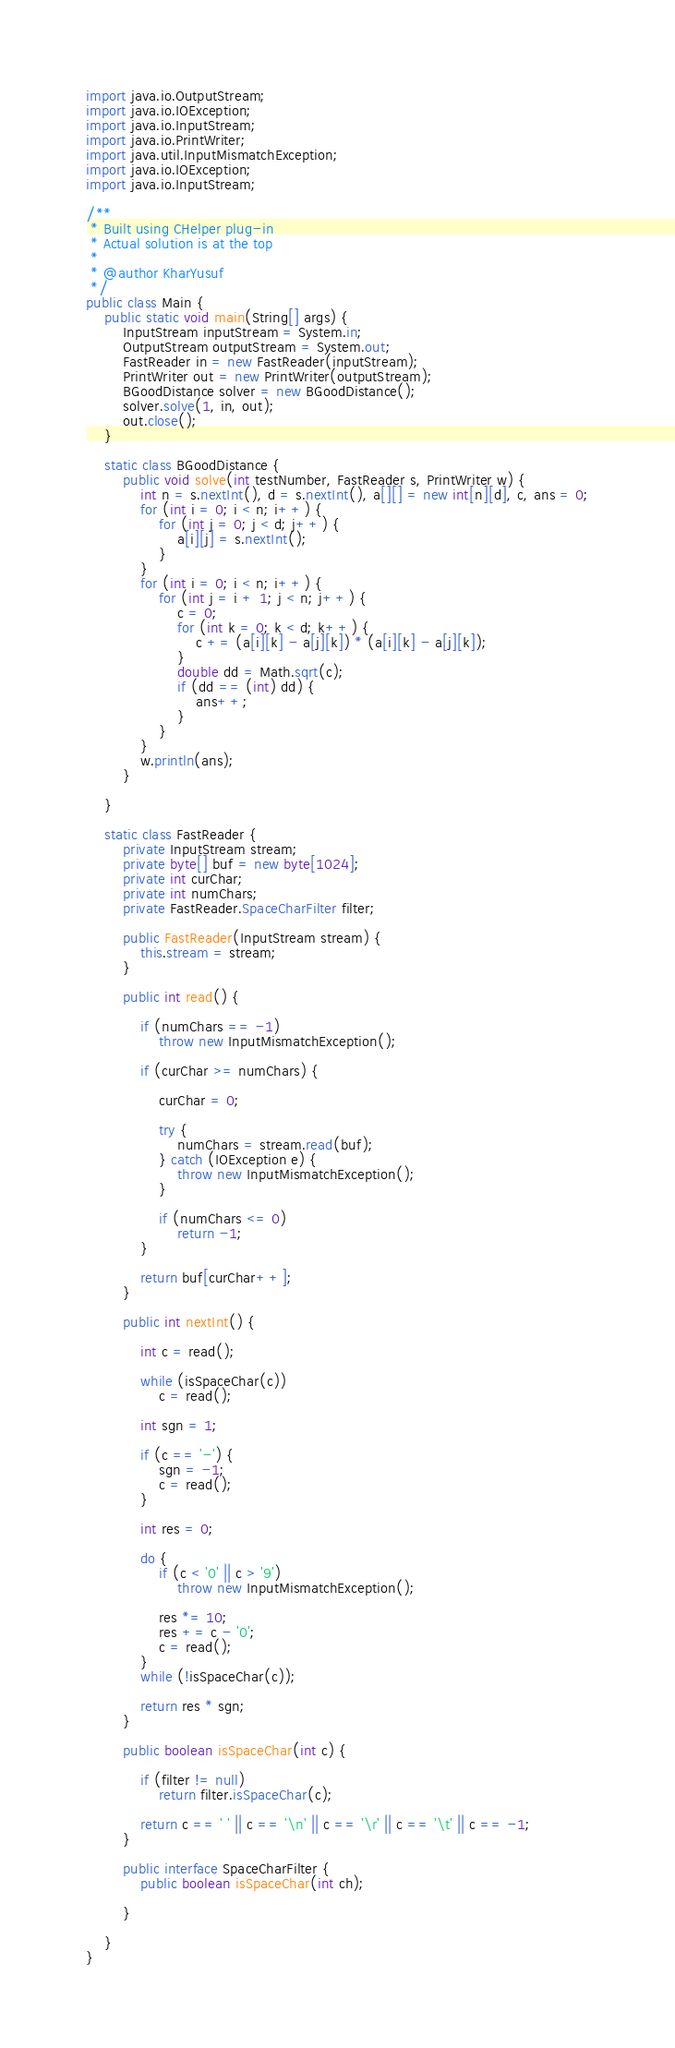<code> <loc_0><loc_0><loc_500><loc_500><_Java_>import java.io.OutputStream;
import java.io.IOException;
import java.io.InputStream;
import java.io.PrintWriter;
import java.util.InputMismatchException;
import java.io.IOException;
import java.io.InputStream;

/**
 * Built using CHelper plug-in
 * Actual solution is at the top
 *
 * @author KharYusuf
 */
public class Main {
    public static void main(String[] args) {
        InputStream inputStream = System.in;
        OutputStream outputStream = System.out;
        FastReader in = new FastReader(inputStream);
        PrintWriter out = new PrintWriter(outputStream);
        BGoodDistance solver = new BGoodDistance();
        solver.solve(1, in, out);
        out.close();
    }

    static class BGoodDistance {
        public void solve(int testNumber, FastReader s, PrintWriter w) {
            int n = s.nextInt(), d = s.nextInt(), a[][] = new int[n][d], c, ans = 0;
            for (int i = 0; i < n; i++) {
                for (int j = 0; j < d; j++) {
                    a[i][j] = s.nextInt();
                }
            }
            for (int i = 0; i < n; i++) {
                for (int j = i + 1; j < n; j++) {
                    c = 0;
                    for (int k = 0; k < d; k++) {
                        c += (a[i][k] - a[j][k]) * (a[i][k] - a[j][k]);
                    }
                    double dd = Math.sqrt(c);
                    if (dd == (int) dd) {
                        ans++;
                    }
                }
            }
            w.println(ans);
        }

    }

    static class FastReader {
        private InputStream stream;
        private byte[] buf = new byte[1024];
        private int curChar;
        private int numChars;
        private FastReader.SpaceCharFilter filter;

        public FastReader(InputStream stream) {
            this.stream = stream;
        }

        public int read() {

            if (numChars == -1)
                throw new InputMismatchException();

            if (curChar >= numChars) {

                curChar = 0;

                try {
                    numChars = stream.read(buf);
                } catch (IOException e) {
                    throw new InputMismatchException();
                }

                if (numChars <= 0)
                    return -1;
            }

            return buf[curChar++];
        }

        public int nextInt() {

            int c = read();

            while (isSpaceChar(c))
                c = read();

            int sgn = 1;

            if (c == '-') {
                sgn = -1;
                c = read();
            }

            int res = 0;

            do {
                if (c < '0' || c > '9')
                    throw new InputMismatchException();

                res *= 10;
                res += c - '0';
                c = read();
            }
            while (!isSpaceChar(c));

            return res * sgn;
        }

        public boolean isSpaceChar(int c) {

            if (filter != null)
                return filter.isSpaceChar(c);

            return c == ' ' || c == '\n' || c == '\r' || c == '\t' || c == -1;
        }

        public interface SpaceCharFilter {
            public boolean isSpaceChar(int ch);

        }

    }
}

</code> 